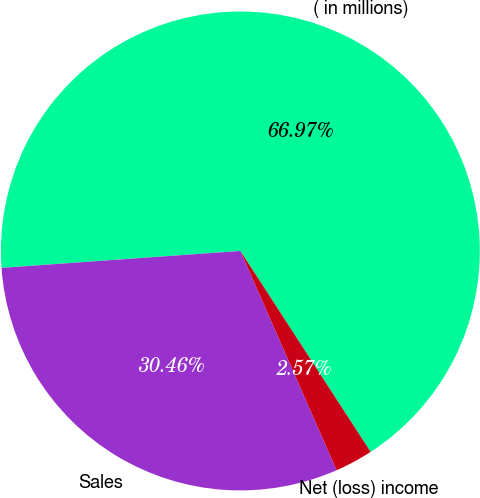Convert chart to OTSL. <chart><loc_0><loc_0><loc_500><loc_500><pie_chart><fcel>( in millions)<fcel>Sales<fcel>Net (loss) income<nl><fcel>66.98%<fcel>30.46%<fcel>2.57%<nl></chart> 